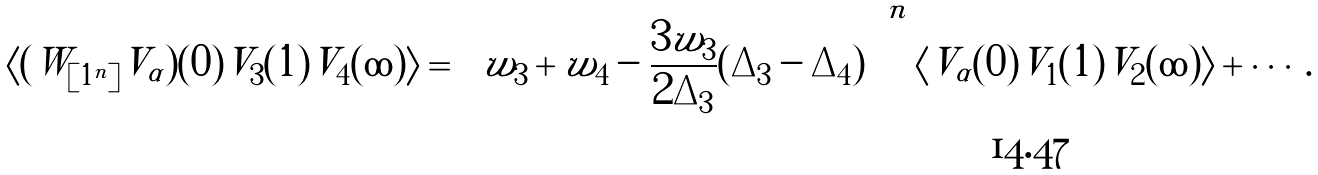<formula> <loc_0><loc_0><loc_500><loc_500>\langle ( W _ { [ 1 ^ { n } ] } V _ { \alpha } ) ( 0 ) V _ { 3 } ( 1 ) V _ { 4 } ( \infty ) \rangle = \left ( w _ { 3 } + w _ { 4 } - \frac { 3 w _ { 3 } } { 2 \Delta _ { 3 } } ( \Delta _ { 3 } - \Delta _ { 4 } ) \right ) ^ { n } \langle V _ { \alpha } ( 0 ) V _ { 1 } ( 1 ) V _ { 2 } ( \infty ) \rangle + \cdots .</formula> 